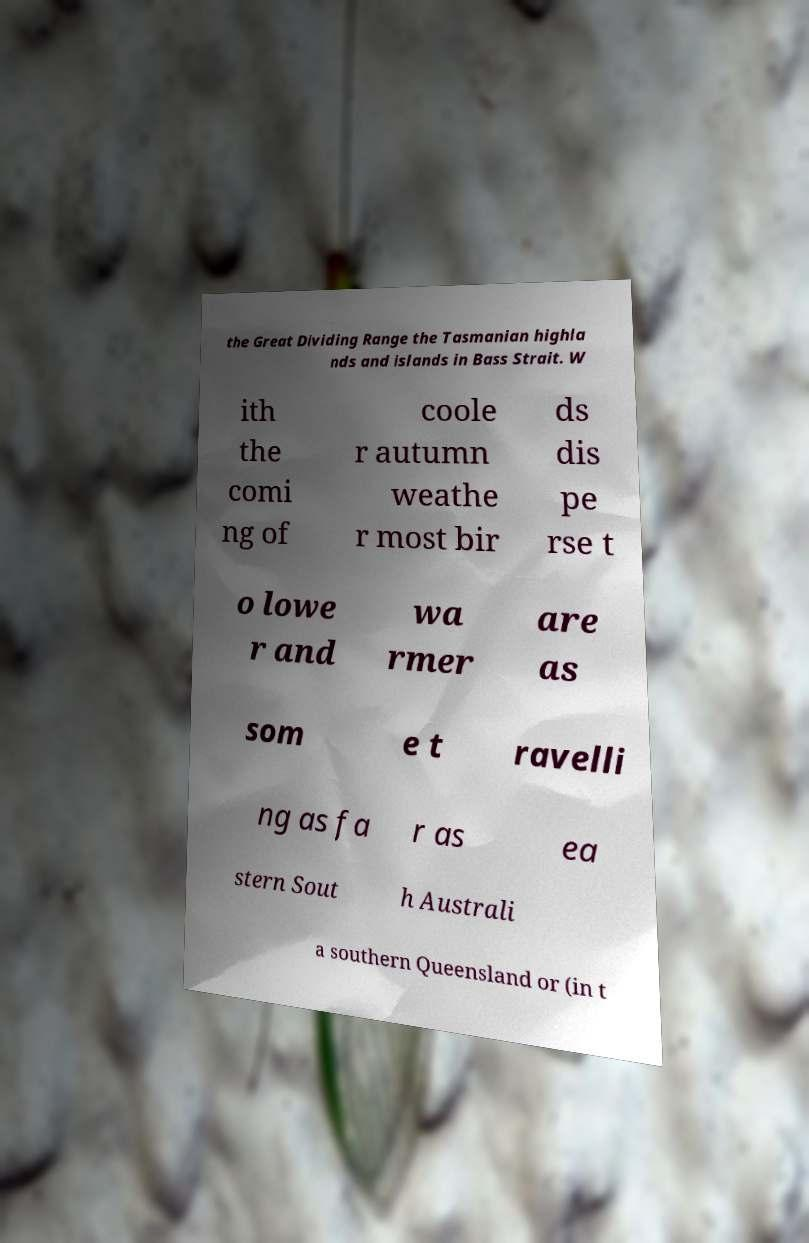Could you extract and type out the text from this image? the Great Dividing Range the Tasmanian highla nds and islands in Bass Strait. W ith the comi ng of coole r autumn weathe r most bir ds dis pe rse t o lowe r and wa rmer are as som e t ravelli ng as fa r as ea stern Sout h Australi a southern Queensland or (in t 